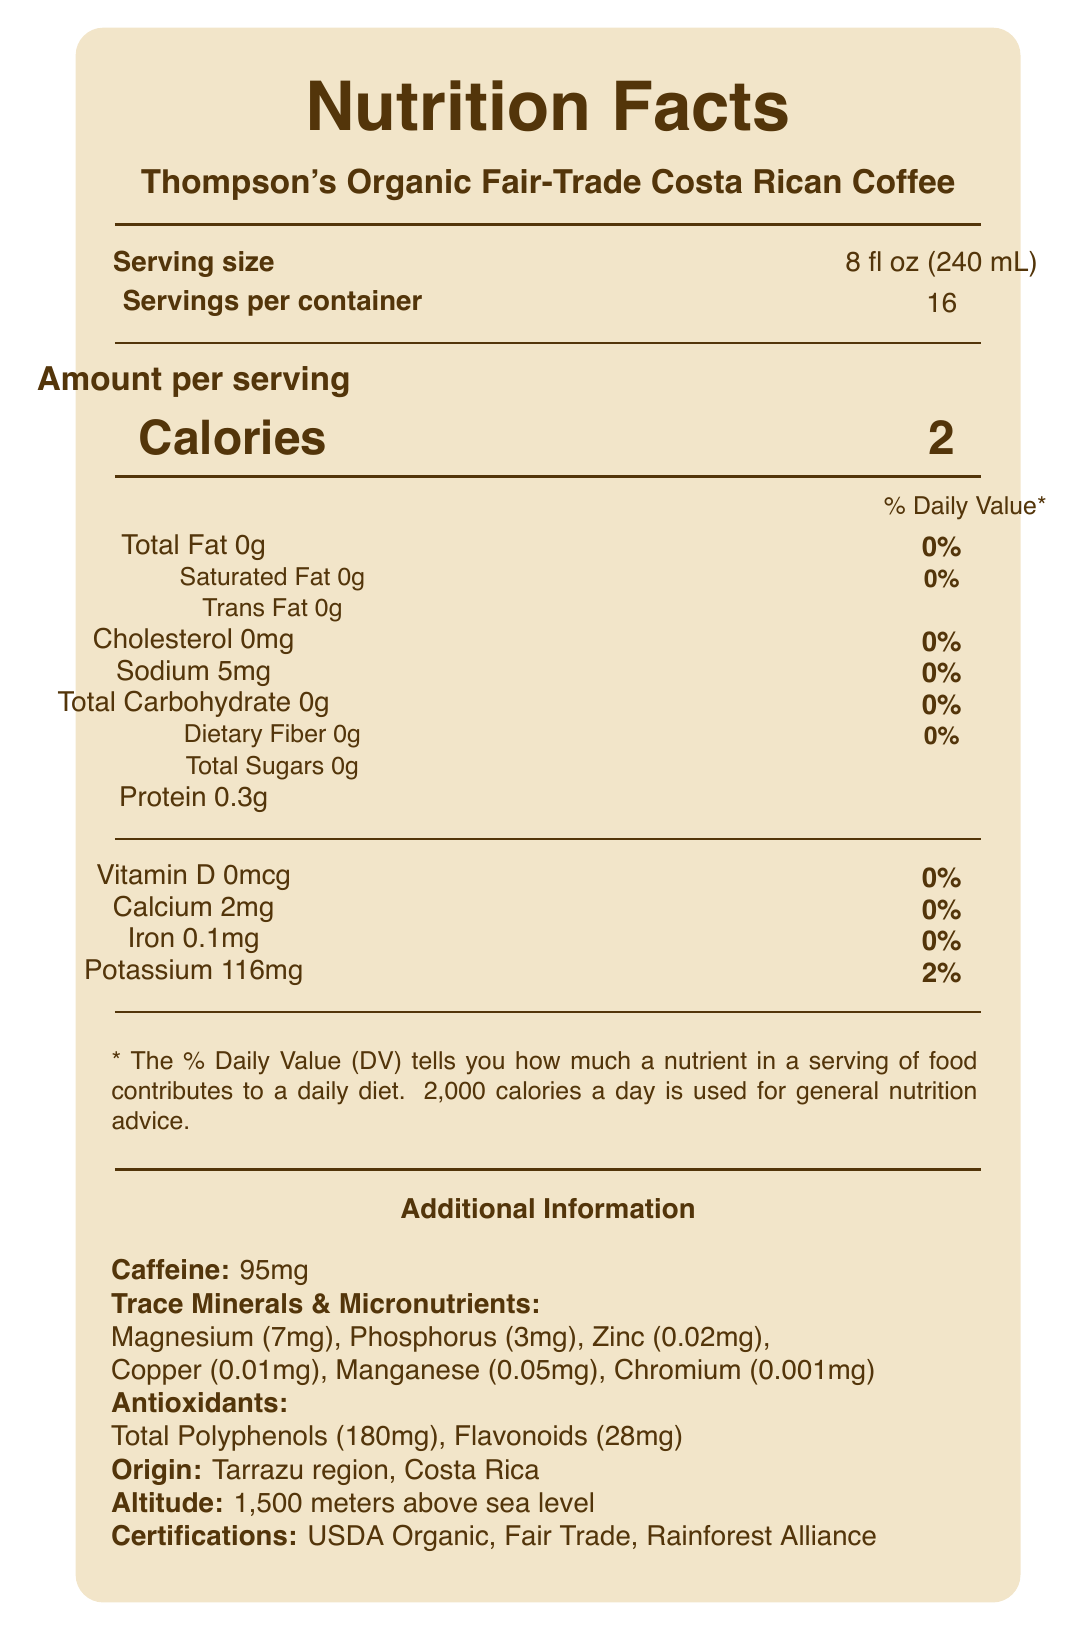What is the serving size for Thompson's Organic Fair-Trade Costa Rican Coffee? The serving size is explicitly stated as "8 fl oz (240 mL)" in the document.
Answer: 8 fl oz (240 mL) How many servings are there per container of this coffee? The document states that there are 16 servings per container.
Answer: 16 What is the calorie count per serving? The document lists the calorie count per serving as 2.
Answer: 2 How much protein is in one serving of this coffee? The document specifies that there is 0.3 grams of protein per serving.
Answer: 0.3g What is the amount of caffeine in one serving of Thompson's Organic Fair-Trade Costa Rican Coffee? The additional information section mentions that each serving contains 95mg of caffeine.
Answer: 95mg How much magnesium is present per serving? The trace minerals and micronutrients section lists magnesium as 7mg per serving.
Answer: 7mg What is the amount of potassium per serving? The nutrition facts state that there are 116mg of potassium per serving, which is also 2% of the daily value.
Answer: 116mg Which certifications does this coffee have? A. USDA Organic B. Fair Trade Certified C. Rainforest Alliance Certified D. All of the above The document lists all three certifications: USDA Organic, Fair Trade Certified, and Rainforest Alliance Certified.
Answer: D. All of the above What are the tasting notes of this coffee? A. Bright citrus acidity B. Milk chocolate C. Honey sweetness D. Nutty undertones E. All of the above The document lists all these tasting notes: bright citrus acidity, milk chocolate, honey sweetness, and nutty undertones.
Answer: E. All of the above Does the coffee contain any dietary fiber? The document specifies that the coffee has 0 grams of dietary fiber.
Answer: No Summarize the key nutritional and additional information for Thompson's Organic Fair-Trade Costa Rican Coffee. The summary combines all the main points from the nutrition facts, additional information, and tasting notes sections of the document.
Answer: The coffee has 2 calories per serving, with 0g of total fat, cholesterol, carbohydrates, and fibers. Each serving contains 0.3g of protein, 5mg sodium, and essential trace minerals and micronutrients like magnesium and potassium. It's certified USDA Organic, Fair Trade, and Rainforest Alliance. The brew method is pour-over, and it offers tasting notes of bright citrus, milk chocolate, honey, and nutty undertones. What is the roast level of this coffee? The document states that the roast level of this coffee is Medium.
Answer: Medium What percentage of the daily value for sodium does one serving of this coffee provide? The sodium content per serving is 5mg, which is labeled as 0% of the daily value in the document.
Answer: 0% What brewing method is recommended for this coffee? The document recommends using the pour-over method with a Hario V60.
Answer: Pour-over using Hario V60 How much zinc is present in one serving of coffee? The trace minerals and micronutrients section lists zinc as 0.02mg per serving.
Answer: 0.02mg Can the origin of the coffee beans be identified from this document? The document specifies that the coffee is from the Tarrazu region in Costa Rica.
Answer: Yes Is there any added sugar in the coffee? The document states that the total sugars amount to 0 grams.
Answer: No Can the environmental sustainability of the coffee be determined from the document? The sustainability statement mentions the coffee is sourced from small-scale farmers committed to sustainable practices and biodiversity conservation.
Answer: Yes What is the daily value percentage for calcium based on one serving of this coffee? The nutrition facts label states that the calcium content is 2mg with a daily value of 0%.
Answer: 0% How much chlorogenic acid does the coffee contain? The trace minerals and micronutrients section lists 35mg of chlorogenic acid per serving.
Answer: 35mg Which coffee grind size is recommended for this product? The document recommends a medium-fine grind size for this coffee.
Answer: Medium-fine Does the document specify the exact month of harvest for this coffee? The document does not mention the specific month of harvest for the coffee beans.
Answer: Not enough information 